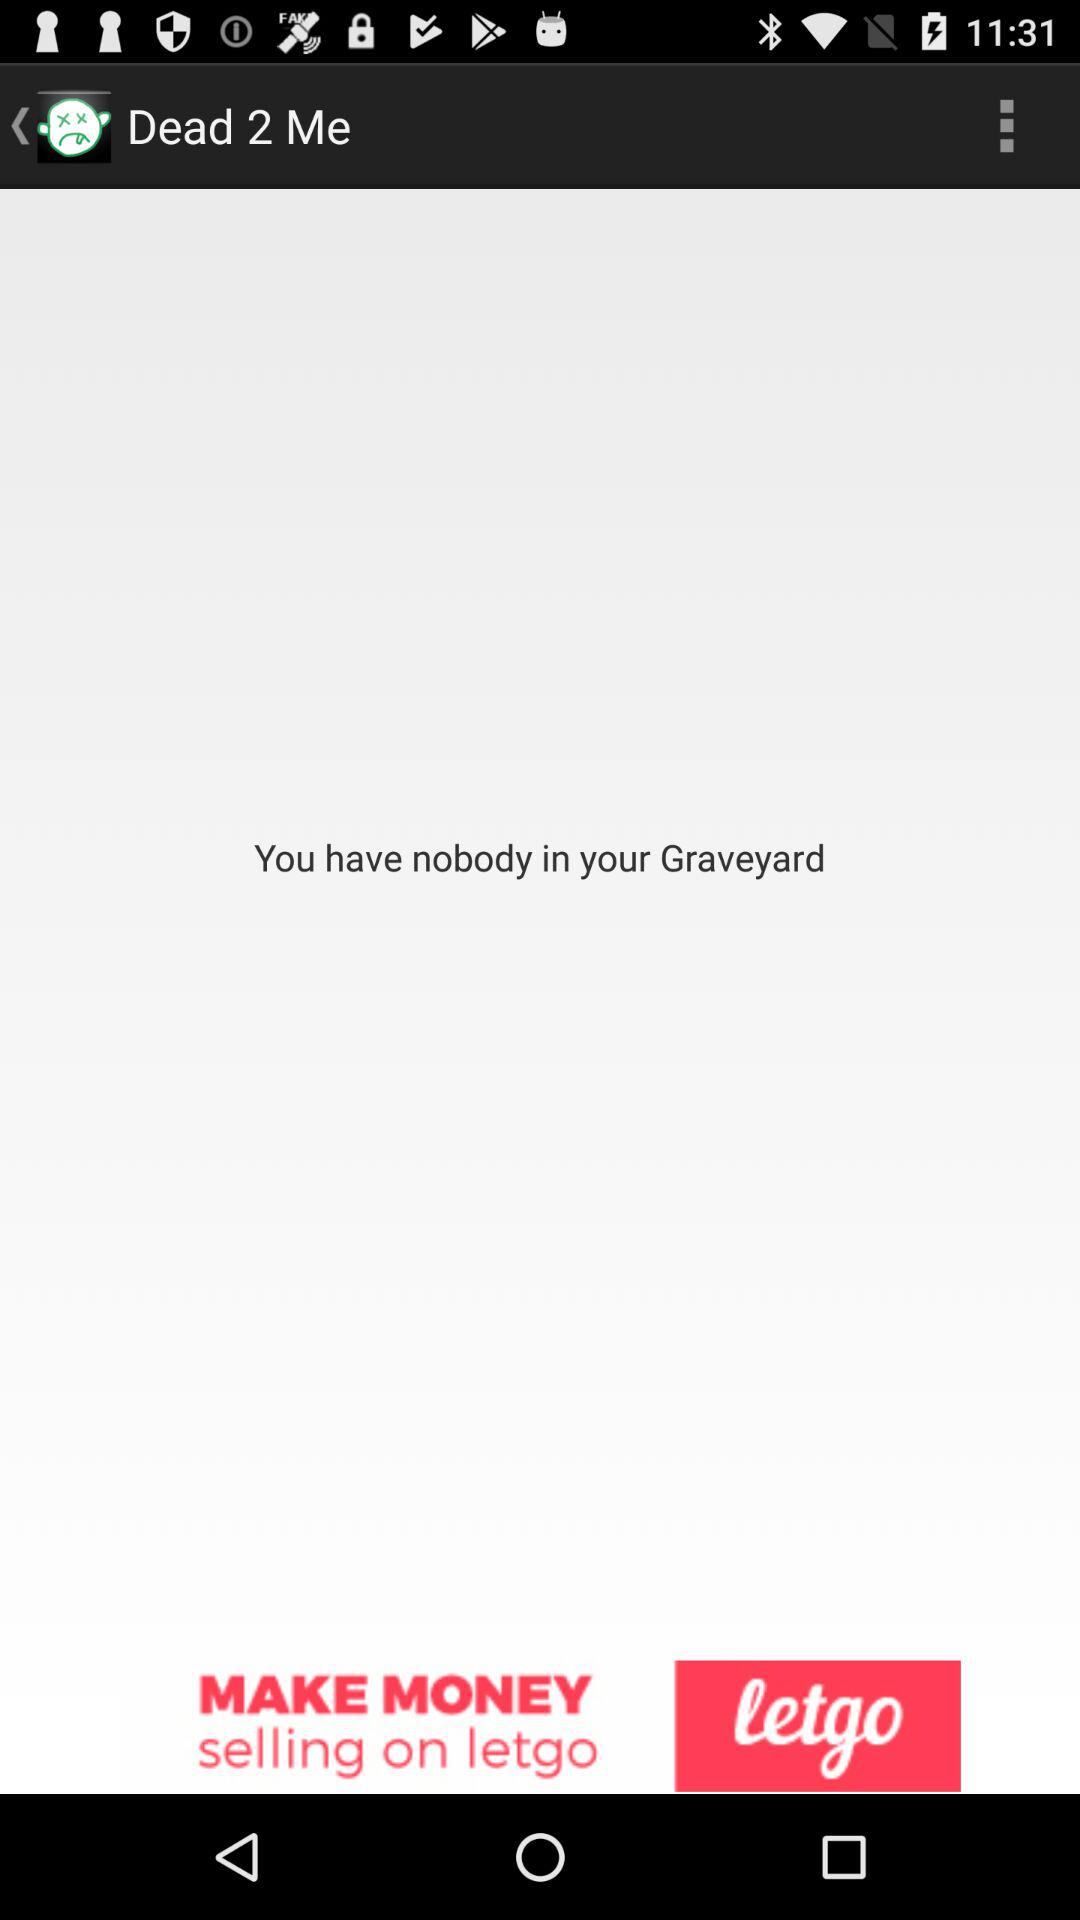What is the name of the application? The name of the application is "Dead 2 Me". 